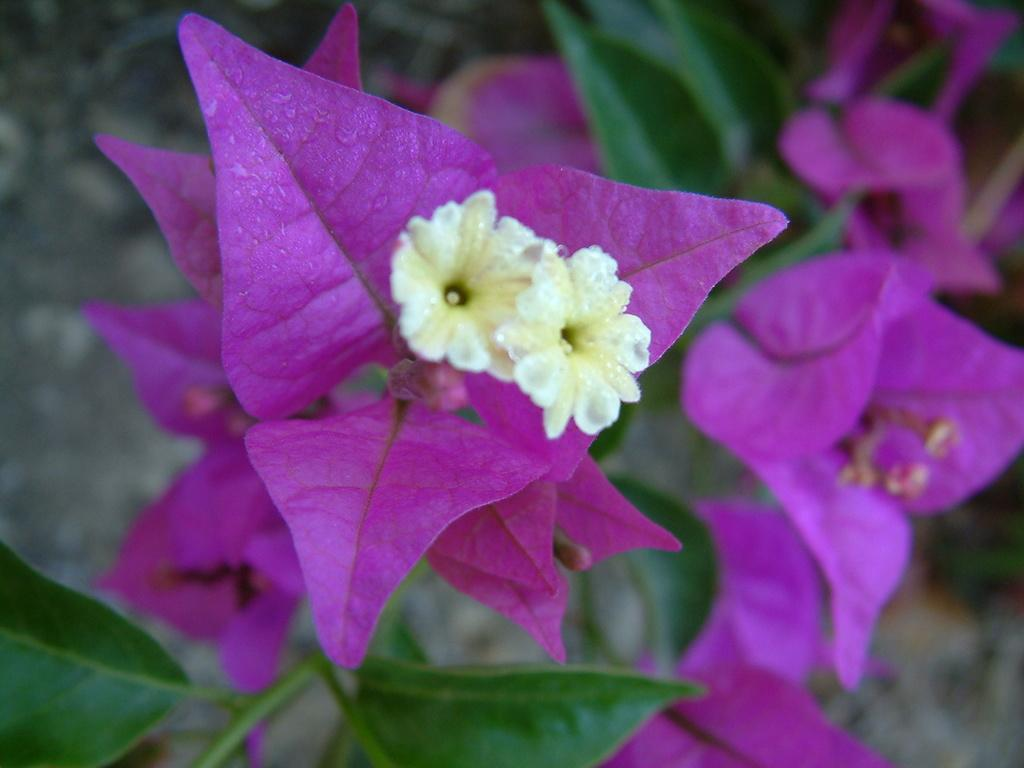What type of plants can be seen in the image? There are flowers in the image. What colors are the flowers? The flowers are pink and white in color. What part of the flowers is green? There are green leaves on the stems of the flowers. How would you describe the background of the image? The background of the image is blurred. How many girls are holding the flowers in the image? There are no girls present in the image; it only features flowers with green leaves on their stems. 